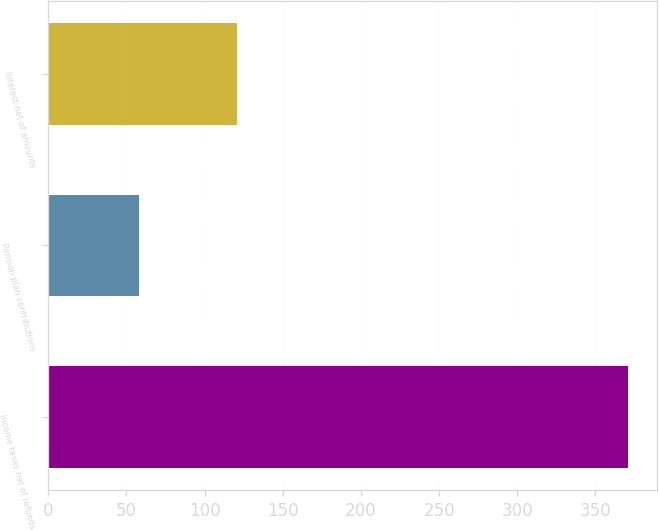Convert chart to OTSL. <chart><loc_0><loc_0><loc_500><loc_500><bar_chart><fcel>Income taxes net of refunds<fcel>Pension plan contributions<fcel>Interest net of amounts<nl><fcel>371<fcel>58<fcel>121<nl></chart> 